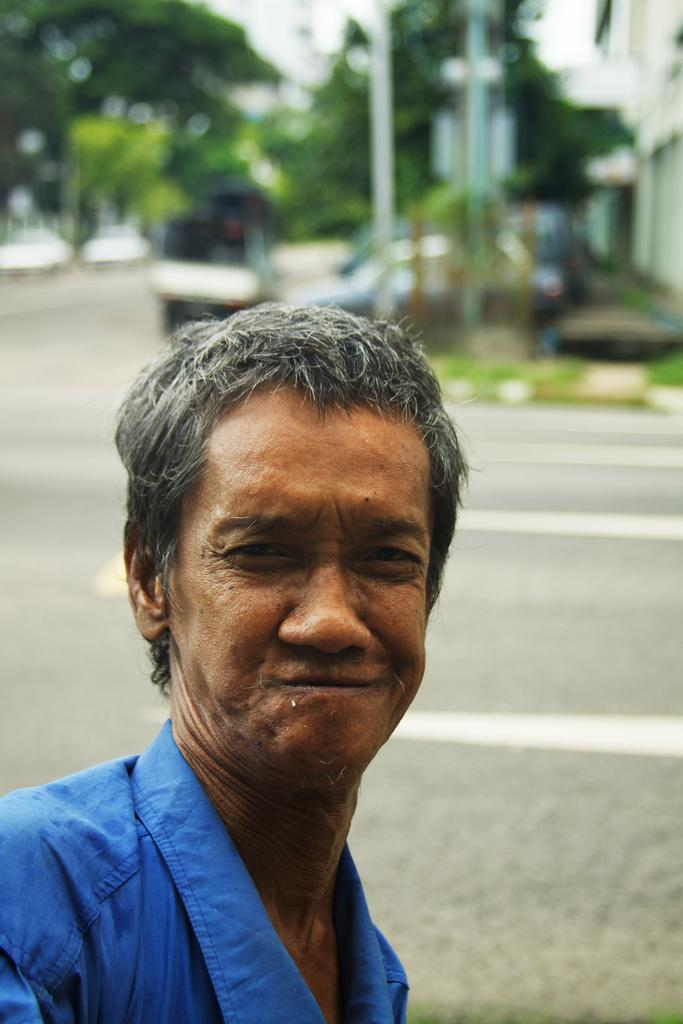Who or what is the main subject of the image? There is a person in the image. What is the person wearing? The person is wearing a blue shirt. What can be seen in the background of the image? Trees and buildings are visible in the background of the image. How is the background of the image depicted? The background is blurred. What type of statement can be seen written on the star in the image? There is no star present in the image, and therefore no statement can be seen written on it. 